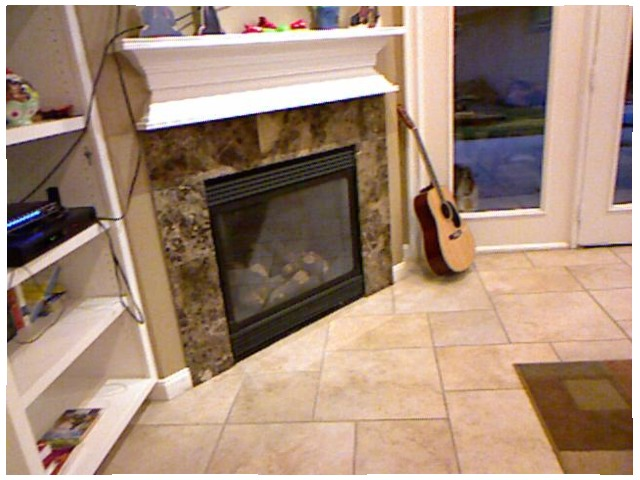<image>
Is the guitar in front of the fire place? No. The guitar is not in front of the fire place. The spatial positioning shows a different relationship between these objects. Where is the guitar in relation to the floor? Is it on the floor? Yes. Looking at the image, I can see the guitar is positioned on top of the floor, with the floor providing support. Where is the violin in relation to the wall? Is it on the wall? No. The violin is not positioned on the wall. They may be near each other, but the violin is not supported by or resting on top of the wall. Is the guitar behind the fireplace? No. The guitar is not behind the fireplace. From this viewpoint, the guitar appears to be positioned elsewhere in the scene. Where is the guitar in relation to the fireplace? Is it to the right of the fireplace? Yes. From this viewpoint, the guitar is positioned to the right side relative to the fireplace. Is the guitar in the fireplace? No. The guitar is not contained within the fireplace. These objects have a different spatial relationship. 